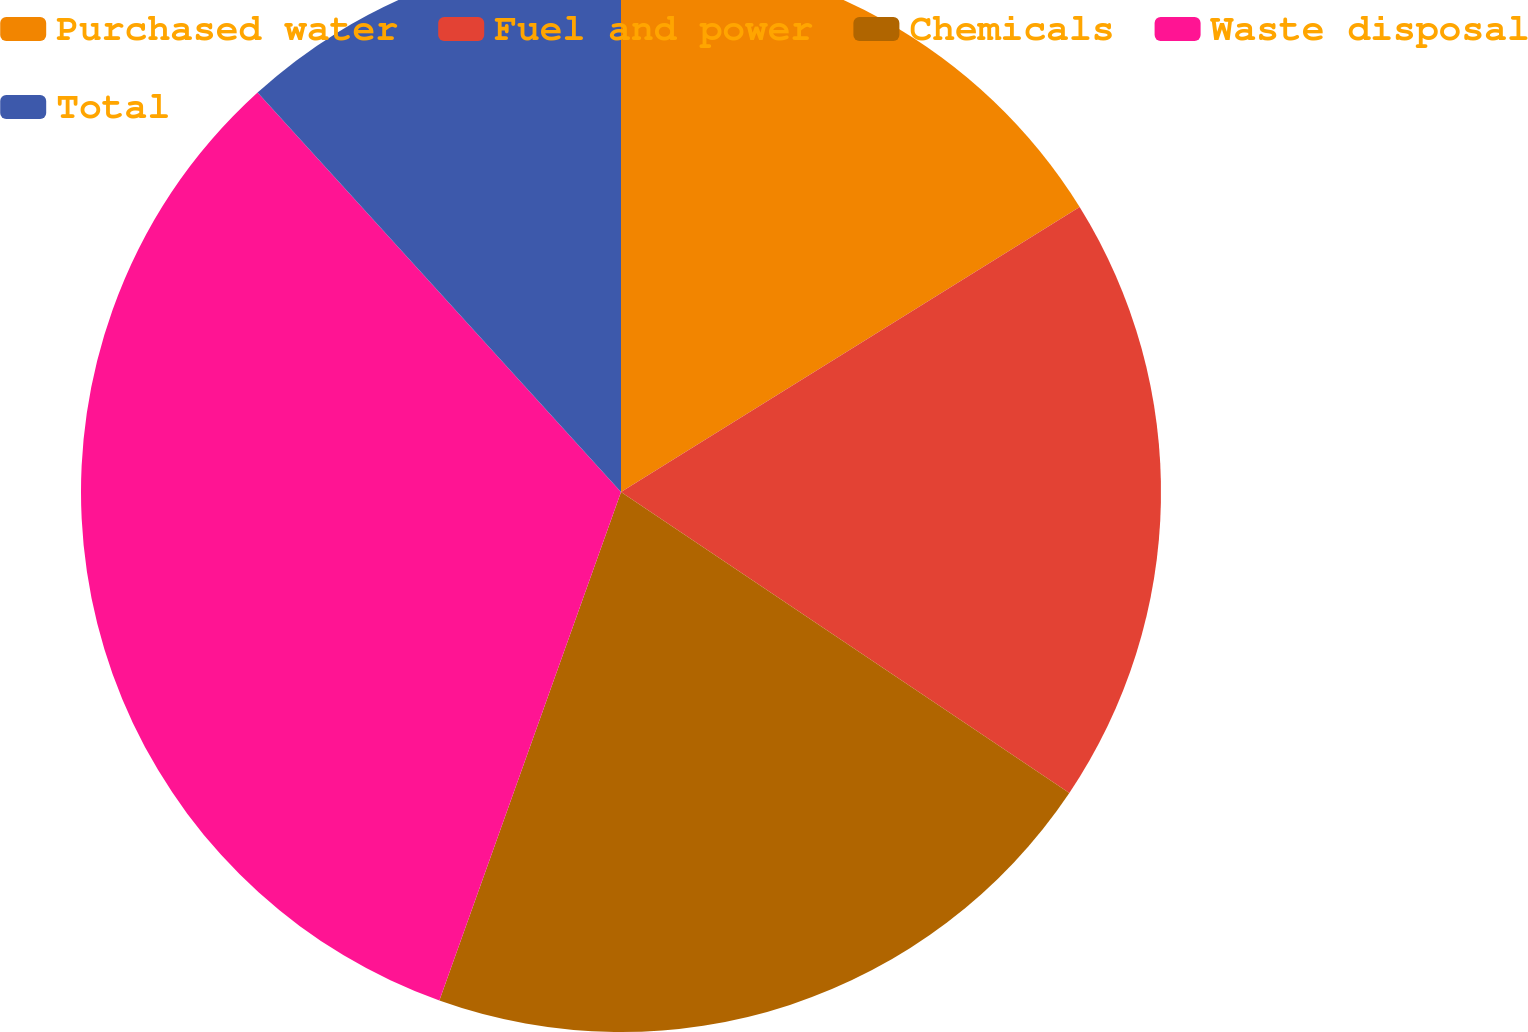Convert chart to OTSL. <chart><loc_0><loc_0><loc_500><loc_500><pie_chart><fcel>Purchased water<fcel>Fuel and power<fcel>Chemicals<fcel>Waste disposal<fcel>Total<nl><fcel>16.15%<fcel>18.26%<fcel>21.05%<fcel>32.79%<fcel>11.75%<nl></chart> 